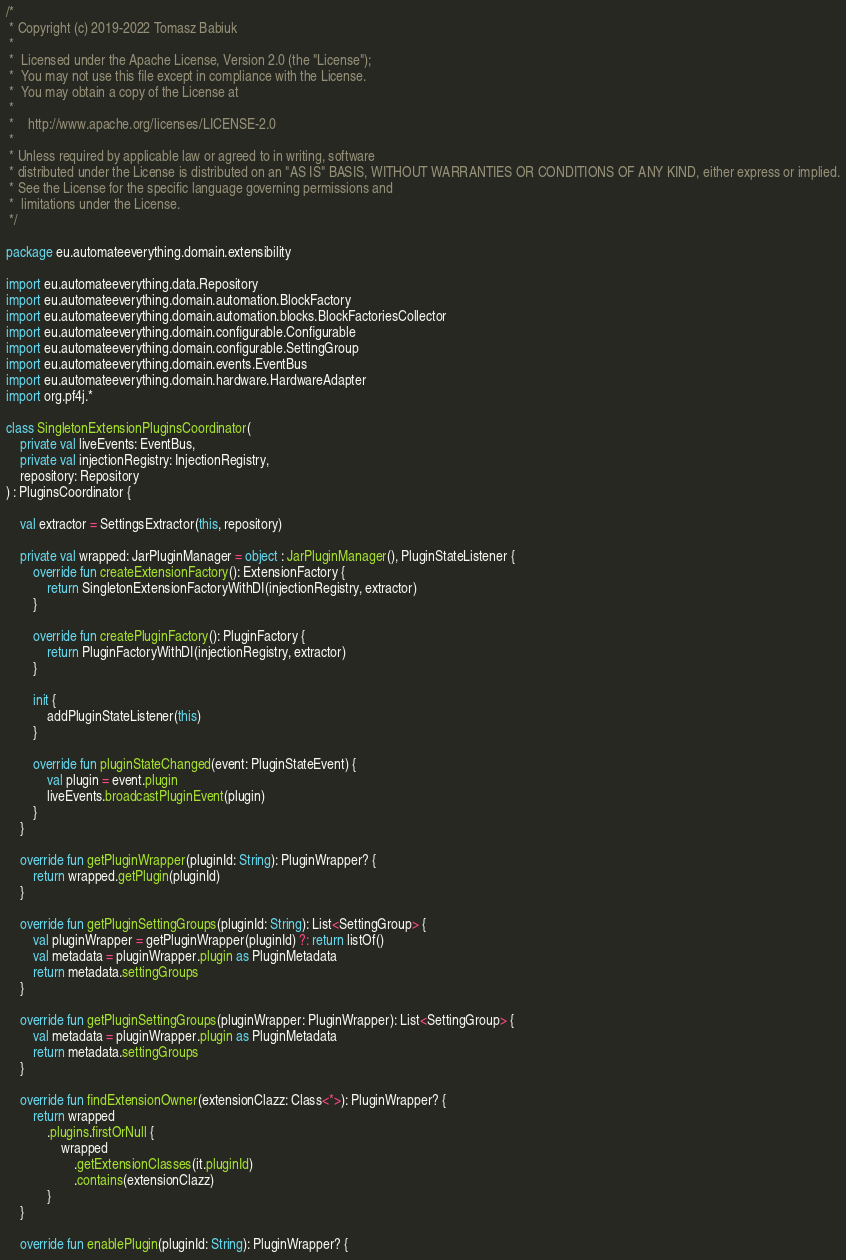Convert code to text. <code><loc_0><loc_0><loc_500><loc_500><_Kotlin_>/*
 * Copyright (c) 2019-2022 Tomasz Babiuk
 *
 *  Licensed under the Apache License, Version 2.0 (the "License");
 *  You may not use this file except in compliance with the License.
 *  You may obtain a copy of the License at
 *
 *    http://www.apache.org/licenses/LICENSE-2.0
 *
 * Unless required by applicable law or agreed to in writing, software
 * distributed under the License is distributed on an "AS IS" BASIS, WITHOUT WARRANTIES OR CONDITIONS OF ANY KIND, either express or implied.
 * See the License for the specific language governing permissions and
 *  limitations under the License.
 */

package eu.automateeverything.domain.extensibility

import eu.automateeverything.data.Repository
import eu.automateeverything.domain.automation.BlockFactory
import eu.automateeverything.domain.automation.blocks.BlockFactoriesCollector
import eu.automateeverything.domain.configurable.Configurable
import eu.automateeverything.domain.configurable.SettingGroup
import eu.automateeverything.domain.events.EventBus
import eu.automateeverything.domain.hardware.HardwareAdapter
import org.pf4j.*

class SingletonExtensionPluginsCoordinator(
    private val liveEvents: EventBus,
    private val injectionRegistry: InjectionRegistry,
    repository: Repository
) : PluginsCoordinator {

    val extractor = SettingsExtractor(this, repository)

    private val wrapped: JarPluginManager = object : JarPluginManager(), PluginStateListener {
        override fun createExtensionFactory(): ExtensionFactory {
            return SingletonExtensionFactoryWithDI(injectionRegistry, extractor)
        }

        override fun createPluginFactory(): PluginFactory {
            return PluginFactoryWithDI(injectionRegistry, extractor)
        }

        init {
            addPluginStateListener(this)
        }

        override fun pluginStateChanged(event: PluginStateEvent) {
            val plugin = event.plugin
            liveEvents.broadcastPluginEvent(plugin)
        }
    }

    override fun getPluginWrapper(pluginId: String): PluginWrapper? {
        return wrapped.getPlugin(pluginId)
    }

    override fun getPluginSettingGroups(pluginId: String): List<SettingGroup> {
        val pluginWrapper = getPluginWrapper(pluginId) ?: return listOf()
        val metadata = pluginWrapper.plugin as PluginMetadata
        return metadata.settingGroups
    }

    override fun getPluginSettingGroups(pluginWrapper: PluginWrapper): List<SettingGroup> {
        val metadata = pluginWrapper.plugin as PluginMetadata
        return metadata.settingGroups
    }

    override fun findExtensionOwner(extensionClazz: Class<*>): PluginWrapper? {
        return wrapped
            .plugins.firstOrNull {
                wrapped
                    .getExtensionClasses(it.pluginId)
                    .contains(extensionClazz)
            }
    }

    override fun enablePlugin(pluginId: String): PluginWrapper? {</code> 